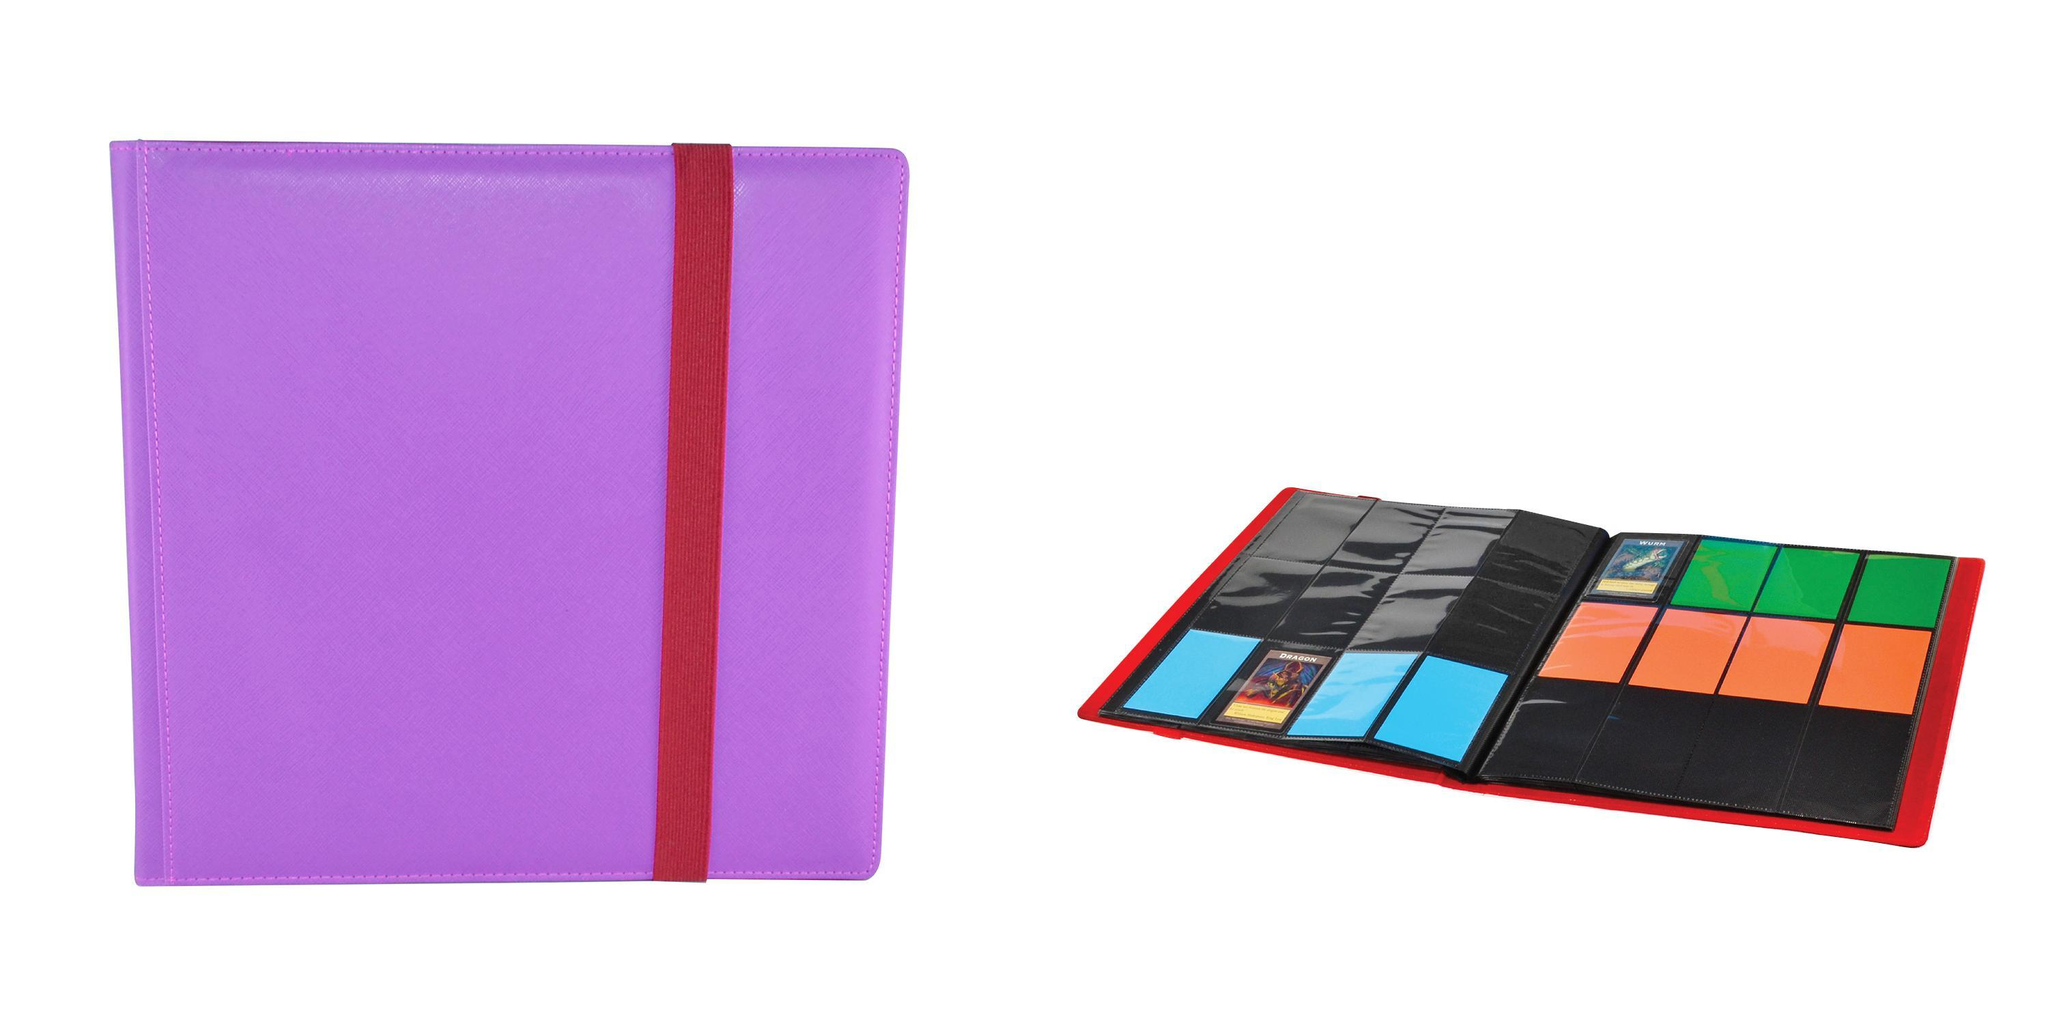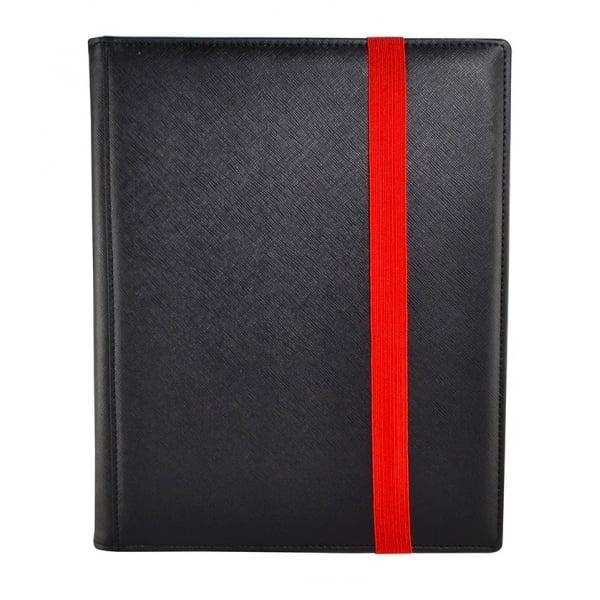The first image is the image on the left, the second image is the image on the right. For the images displayed, is the sentence "An image depicts a purple binder next to an open binder." factually correct? Answer yes or no. Yes. 